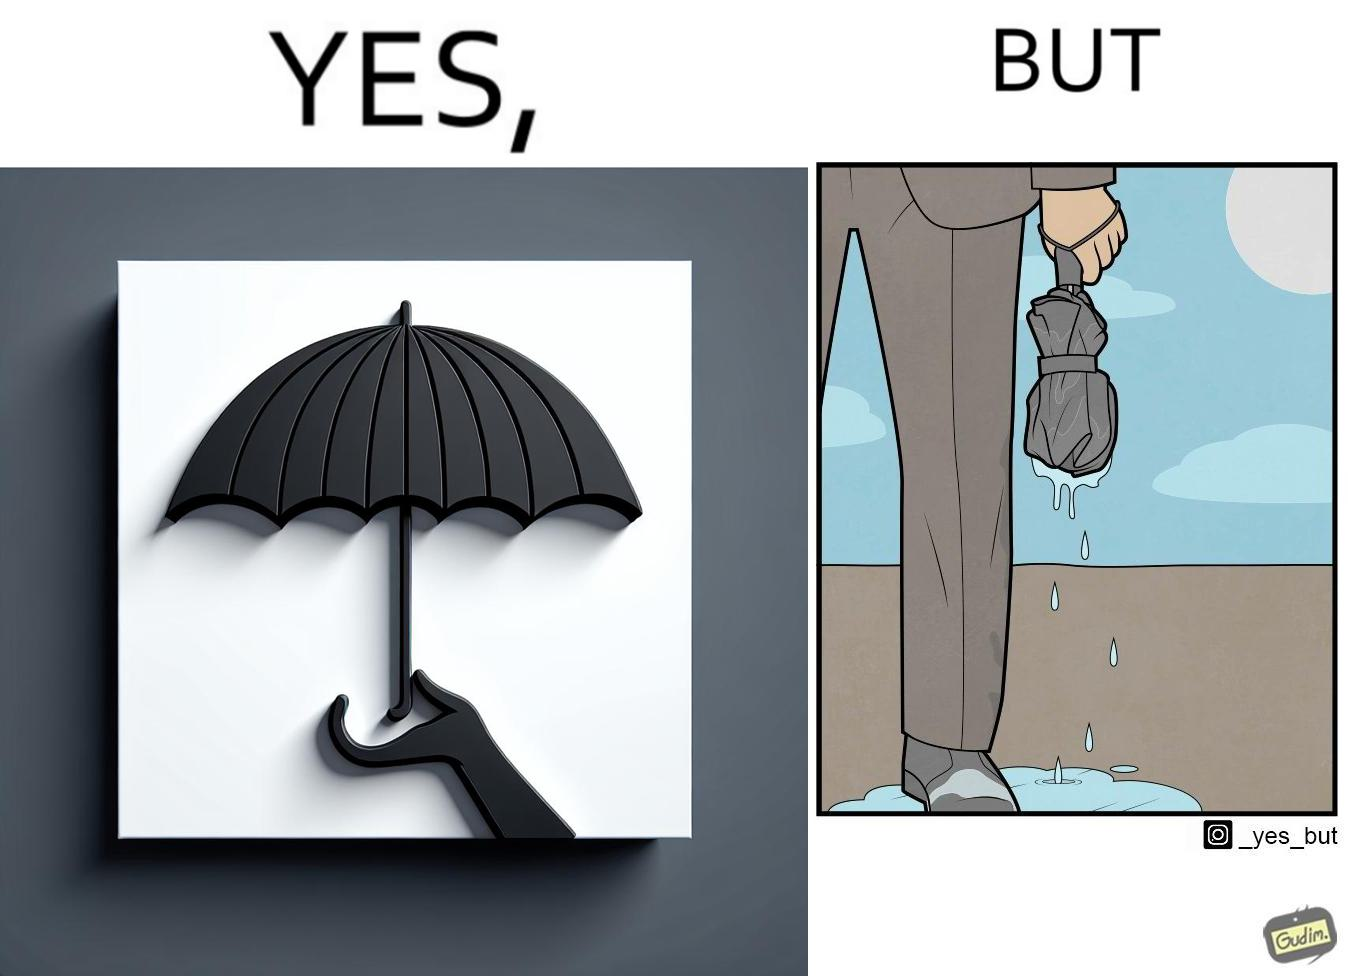What does this image depict? The image is funny because while the umbrella helps a person avoid getting wet from rain, when the rain stops and the umbrella is folded, the wet umbrella iteself drips water on the person holding it. 